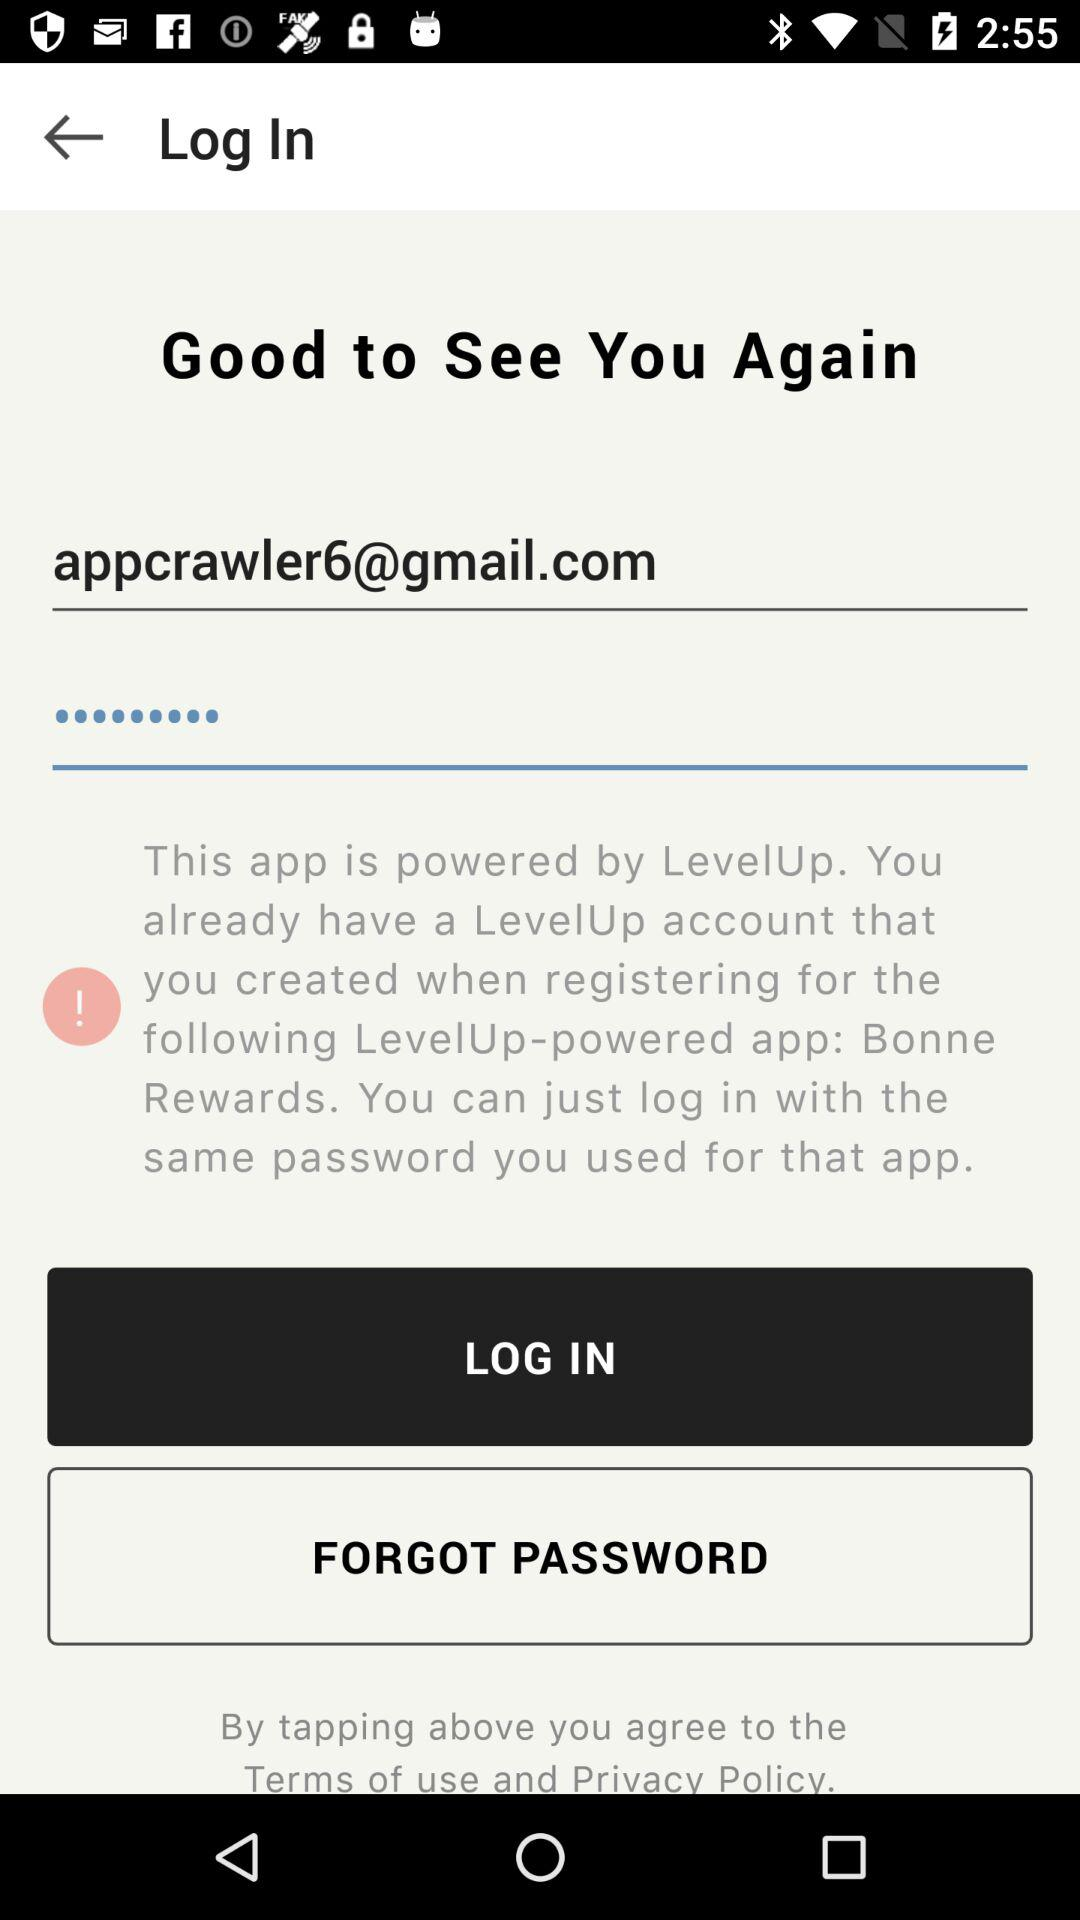What Gmail account is used there? The Gmail account is appcrawler6@gmail.com. 